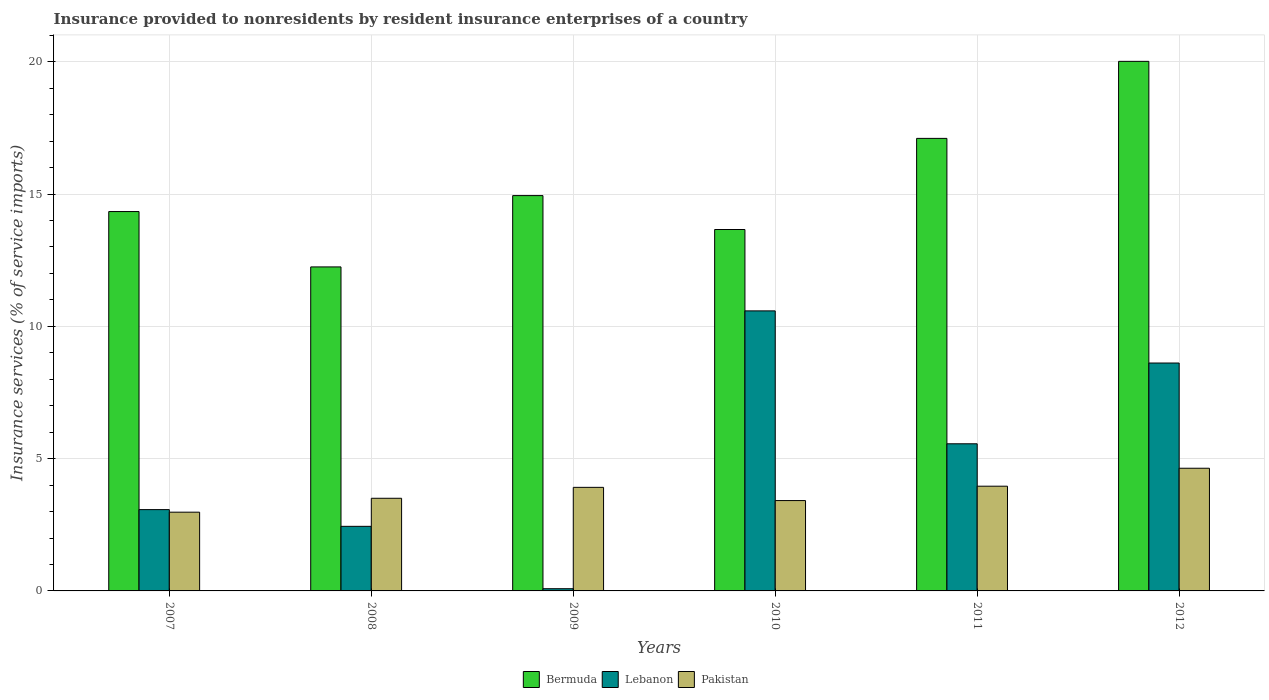How many bars are there on the 4th tick from the left?
Keep it short and to the point. 3. How many bars are there on the 2nd tick from the right?
Make the answer very short. 3. What is the label of the 1st group of bars from the left?
Your answer should be compact. 2007. In how many cases, is the number of bars for a given year not equal to the number of legend labels?
Your answer should be compact. 0. What is the insurance provided to nonresidents in Bermuda in 2011?
Ensure brevity in your answer.  17.1. Across all years, what is the maximum insurance provided to nonresidents in Bermuda?
Ensure brevity in your answer.  20.02. Across all years, what is the minimum insurance provided to nonresidents in Lebanon?
Your answer should be compact. 0.08. In which year was the insurance provided to nonresidents in Lebanon maximum?
Provide a succinct answer. 2010. In which year was the insurance provided to nonresidents in Lebanon minimum?
Offer a very short reply. 2009. What is the total insurance provided to nonresidents in Lebanon in the graph?
Offer a very short reply. 30.36. What is the difference between the insurance provided to nonresidents in Bermuda in 2008 and that in 2010?
Provide a short and direct response. -1.41. What is the difference between the insurance provided to nonresidents in Pakistan in 2007 and the insurance provided to nonresidents in Lebanon in 2009?
Make the answer very short. 2.89. What is the average insurance provided to nonresidents in Lebanon per year?
Offer a very short reply. 5.06. In the year 2011, what is the difference between the insurance provided to nonresidents in Pakistan and insurance provided to nonresidents in Lebanon?
Give a very brief answer. -1.6. In how many years, is the insurance provided to nonresidents in Bermuda greater than 1 %?
Your answer should be very brief. 6. What is the ratio of the insurance provided to nonresidents in Pakistan in 2007 to that in 2009?
Your answer should be compact. 0.76. Is the insurance provided to nonresidents in Pakistan in 2009 less than that in 2010?
Provide a succinct answer. No. What is the difference between the highest and the second highest insurance provided to nonresidents in Bermuda?
Keep it short and to the point. 2.91. What is the difference between the highest and the lowest insurance provided to nonresidents in Lebanon?
Offer a very short reply. 10.5. In how many years, is the insurance provided to nonresidents in Bermuda greater than the average insurance provided to nonresidents in Bermuda taken over all years?
Ensure brevity in your answer.  2. What does the 2nd bar from the left in 2008 represents?
Your response must be concise. Lebanon. What does the 2nd bar from the right in 2007 represents?
Offer a very short reply. Lebanon. Does the graph contain any zero values?
Your answer should be very brief. No. Does the graph contain grids?
Ensure brevity in your answer.  Yes. How are the legend labels stacked?
Ensure brevity in your answer.  Horizontal. What is the title of the graph?
Your response must be concise. Insurance provided to nonresidents by resident insurance enterprises of a country. What is the label or title of the Y-axis?
Give a very brief answer. Insurance services (% of service imports). What is the Insurance services (% of service imports) of Bermuda in 2007?
Your response must be concise. 14.34. What is the Insurance services (% of service imports) in Lebanon in 2007?
Provide a succinct answer. 3.07. What is the Insurance services (% of service imports) of Pakistan in 2007?
Offer a very short reply. 2.98. What is the Insurance services (% of service imports) in Bermuda in 2008?
Offer a terse response. 12.25. What is the Insurance services (% of service imports) of Lebanon in 2008?
Your answer should be very brief. 2.44. What is the Insurance services (% of service imports) in Pakistan in 2008?
Your answer should be compact. 3.5. What is the Insurance services (% of service imports) in Bermuda in 2009?
Keep it short and to the point. 14.94. What is the Insurance services (% of service imports) of Lebanon in 2009?
Your response must be concise. 0.08. What is the Insurance services (% of service imports) in Pakistan in 2009?
Make the answer very short. 3.91. What is the Insurance services (% of service imports) of Bermuda in 2010?
Make the answer very short. 13.66. What is the Insurance services (% of service imports) of Lebanon in 2010?
Your response must be concise. 10.58. What is the Insurance services (% of service imports) of Pakistan in 2010?
Provide a succinct answer. 3.41. What is the Insurance services (% of service imports) in Bermuda in 2011?
Your answer should be very brief. 17.1. What is the Insurance services (% of service imports) in Lebanon in 2011?
Make the answer very short. 5.56. What is the Insurance services (% of service imports) of Pakistan in 2011?
Your answer should be very brief. 3.96. What is the Insurance services (% of service imports) of Bermuda in 2012?
Your answer should be compact. 20.02. What is the Insurance services (% of service imports) of Lebanon in 2012?
Ensure brevity in your answer.  8.61. What is the Insurance services (% of service imports) of Pakistan in 2012?
Offer a terse response. 4.64. Across all years, what is the maximum Insurance services (% of service imports) of Bermuda?
Keep it short and to the point. 20.02. Across all years, what is the maximum Insurance services (% of service imports) of Lebanon?
Make the answer very short. 10.58. Across all years, what is the maximum Insurance services (% of service imports) of Pakistan?
Your response must be concise. 4.64. Across all years, what is the minimum Insurance services (% of service imports) of Bermuda?
Provide a short and direct response. 12.25. Across all years, what is the minimum Insurance services (% of service imports) in Lebanon?
Offer a very short reply. 0.08. Across all years, what is the minimum Insurance services (% of service imports) in Pakistan?
Your answer should be compact. 2.98. What is the total Insurance services (% of service imports) of Bermuda in the graph?
Offer a very short reply. 92.3. What is the total Insurance services (% of service imports) of Lebanon in the graph?
Your response must be concise. 30.36. What is the total Insurance services (% of service imports) in Pakistan in the graph?
Your answer should be compact. 22.4. What is the difference between the Insurance services (% of service imports) in Bermuda in 2007 and that in 2008?
Give a very brief answer. 2.09. What is the difference between the Insurance services (% of service imports) in Lebanon in 2007 and that in 2008?
Make the answer very short. 0.63. What is the difference between the Insurance services (% of service imports) in Pakistan in 2007 and that in 2008?
Offer a terse response. -0.53. What is the difference between the Insurance services (% of service imports) in Bermuda in 2007 and that in 2009?
Provide a succinct answer. -0.6. What is the difference between the Insurance services (% of service imports) of Lebanon in 2007 and that in 2009?
Make the answer very short. 2.99. What is the difference between the Insurance services (% of service imports) in Pakistan in 2007 and that in 2009?
Your answer should be very brief. -0.94. What is the difference between the Insurance services (% of service imports) of Bermuda in 2007 and that in 2010?
Your response must be concise. 0.68. What is the difference between the Insurance services (% of service imports) of Lebanon in 2007 and that in 2010?
Provide a succinct answer. -7.51. What is the difference between the Insurance services (% of service imports) in Pakistan in 2007 and that in 2010?
Provide a short and direct response. -0.44. What is the difference between the Insurance services (% of service imports) in Bermuda in 2007 and that in 2011?
Give a very brief answer. -2.77. What is the difference between the Insurance services (% of service imports) in Lebanon in 2007 and that in 2011?
Offer a very short reply. -2.49. What is the difference between the Insurance services (% of service imports) of Pakistan in 2007 and that in 2011?
Your response must be concise. -0.98. What is the difference between the Insurance services (% of service imports) of Bermuda in 2007 and that in 2012?
Keep it short and to the point. -5.68. What is the difference between the Insurance services (% of service imports) in Lebanon in 2007 and that in 2012?
Provide a short and direct response. -5.54. What is the difference between the Insurance services (% of service imports) in Pakistan in 2007 and that in 2012?
Give a very brief answer. -1.66. What is the difference between the Insurance services (% of service imports) in Bermuda in 2008 and that in 2009?
Your answer should be very brief. -2.7. What is the difference between the Insurance services (% of service imports) in Lebanon in 2008 and that in 2009?
Ensure brevity in your answer.  2.36. What is the difference between the Insurance services (% of service imports) of Pakistan in 2008 and that in 2009?
Keep it short and to the point. -0.41. What is the difference between the Insurance services (% of service imports) in Bermuda in 2008 and that in 2010?
Give a very brief answer. -1.41. What is the difference between the Insurance services (% of service imports) in Lebanon in 2008 and that in 2010?
Offer a very short reply. -8.14. What is the difference between the Insurance services (% of service imports) of Pakistan in 2008 and that in 2010?
Your response must be concise. 0.09. What is the difference between the Insurance services (% of service imports) in Bermuda in 2008 and that in 2011?
Your answer should be compact. -4.86. What is the difference between the Insurance services (% of service imports) of Lebanon in 2008 and that in 2011?
Your response must be concise. -3.12. What is the difference between the Insurance services (% of service imports) in Pakistan in 2008 and that in 2011?
Your response must be concise. -0.46. What is the difference between the Insurance services (% of service imports) in Bermuda in 2008 and that in 2012?
Your answer should be compact. -7.77. What is the difference between the Insurance services (% of service imports) of Lebanon in 2008 and that in 2012?
Offer a very short reply. -6.17. What is the difference between the Insurance services (% of service imports) of Pakistan in 2008 and that in 2012?
Offer a very short reply. -1.14. What is the difference between the Insurance services (% of service imports) of Bermuda in 2009 and that in 2010?
Provide a succinct answer. 1.28. What is the difference between the Insurance services (% of service imports) of Lebanon in 2009 and that in 2010?
Give a very brief answer. -10.5. What is the difference between the Insurance services (% of service imports) of Pakistan in 2009 and that in 2010?
Your response must be concise. 0.5. What is the difference between the Insurance services (% of service imports) in Bermuda in 2009 and that in 2011?
Your answer should be compact. -2.16. What is the difference between the Insurance services (% of service imports) of Lebanon in 2009 and that in 2011?
Offer a terse response. -5.48. What is the difference between the Insurance services (% of service imports) in Pakistan in 2009 and that in 2011?
Ensure brevity in your answer.  -0.04. What is the difference between the Insurance services (% of service imports) of Bermuda in 2009 and that in 2012?
Your answer should be compact. -5.07. What is the difference between the Insurance services (% of service imports) in Lebanon in 2009 and that in 2012?
Offer a very short reply. -8.53. What is the difference between the Insurance services (% of service imports) of Pakistan in 2009 and that in 2012?
Your answer should be very brief. -0.72. What is the difference between the Insurance services (% of service imports) in Bermuda in 2010 and that in 2011?
Provide a short and direct response. -3.44. What is the difference between the Insurance services (% of service imports) in Lebanon in 2010 and that in 2011?
Your answer should be compact. 5.02. What is the difference between the Insurance services (% of service imports) in Pakistan in 2010 and that in 2011?
Make the answer very short. -0.54. What is the difference between the Insurance services (% of service imports) in Bermuda in 2010 and that in 2012?
Offer a very short reply. -6.36. What is the difference between the Insurance services (% of service imports) of Lebanon in 2010 and that in 2012?
Provide a short and direct response. 1.97. What is the difference between the Insurance services (% of service imports) in Pakistan in 2010 and that in 2012?
Offer a terse response. -1.22. What is the difference between the Insurance services (% of service imports) of Bermuda in 2011 and that in 2012?
Provide a short and direct response. -2.91. What is the difference between the Insurance services (% of service imports) in Lebanon in 2011 and that in 2012?
Offer a very short reply. -3.05. What is the difference between the Insurance services (% of service imports) in Pakistan in 2011 and that in 2012?
Provide a succinct answer. -0.68. What is the difference between the Insurance services (% of service imports) of Bermuda in 2007 and the Insurance services (% of service imports) of Lebanon in 2008?
Provide a succinct answer. 11.9. What is the difference between the Insurance services (% of service imports) of Bermuda in 2007 and the Insurance services (% of service imports) of Pakistan in 2008?
Your response must be concise. 10.84. What is the difference between the Insurance services (% of service imports) of Lebanon in 2007 and the Insurance services (% of service imports) of Pakistan in 2008?
Make the answer very short. -0.43. What is the difference between the Insurance services (% of service imports) in Bermuda in 2007 and the Insurance services (% of service imports) in Lebanon in 2009?
Make the answer very short. 14.25. What is the difference between the Insurance services (% of service imports) in Bermuda in 2007 and the Insurance services (% of service imports) in Pakistan in 2009?
Give a very brief answer. 10.42. What is the difference between the Insurance services (% of service imports) in Lebanon in 2007 and the Insurance services (% of service imports) in Pakistan in 2009?
Offer a terse response. -0.84. What is the difference between the Insurance services (% of service imports) in Bermuda in 2007 and the Insurance services (% of service imports) in Lebanon in 2010?
Your answer should be compact. 3.75. What is the difference between the Insurance services (% of service imports) of Bermuda in 2007 and the Insurance services (% of service imports) of Pakistan in 2010?
Offer a very short reply. 10.92. What is the difference between the Insurance services (% of service imports) in Lebanon in 2007 and the Insurance services (% of service imports) in Pakistan in 2010?
Provide a short and direct response. -0.34. What is the difference between the Insurance services (% of service imports) of Bermuda in 2007 and the Insurance services (% of service imports) of Lebanon in 2011?
Your answer should be very brief. 8.78. What is the difference between the Insurance services (% of service imports) in Bermuda in 2007 and the Insurance services (% of service imports) in Pakistan in 2011?
Your answer should be very brief. 10.38. What is the difference between the Insurance services (% of service imports) of Lebanon in 2007 and the Insurance services (% of service imports) of Pakistan in 2011?
Make the answer very short. -0.89. What is the difference between the Insurance services (% of service imports) of Bermuda in 2007 and the Insurance services (% of service imports) of Lebanon in 2012?
Your answer should be very brief. 5.72. What is the difference between the Insurance services (% of service imports) in Bermuda in 2007 and the Insurance services (% of service imports) in Pakistan in 2012?
Ensure brevity in your answer.  9.7. What is the difference between the Insurance services (% of service imports) of Lebanon in 2007 and the Insurance services (% of service imports) of Pakistan in 2012?
Your answer should be compact. -1.56. What is the difference between the Insurance services (% of service imports) of Bermuda in 2008 and the Insurance services (% of service imports) of Lebanon in 2009?
Offer a very short reply. 12.16. What is the difference between the Insurance services (% of service imports) in Bermuda in 2008 and the Insurance services (% of service imports) in Pakistan in 2009?
Ensure brevity in your answer.  8.33. What is the difference between the Insurance services (% of service imports) of Lebanon in 2008 and the Insurance services (% of service imports) of Pakistan in 2009?
Provide a succinct answer. -1.47. What is the difference between the Insurance services (% of service imports) in Bermuda in 2008 and the Insurance services (% of service imports) in Lebanon in 2010?
Offer a terse response. 1.66. What is the difference between the Insurance services (% of service imports) of Bermuda in 2008 and the Insurance services (% of service imports) of Pakistan in 2010?
Give a very brief answer. 8.83. What is the difference between the Insurance services (% of service imports) of Lebanon in 2008 and the Insurance services (% of service imports) of Pakistan in 2010?
Offer a very short reply. -0.97. What is the difference between the Insurance services (% of service imports) of Bermuda in 2008 and the Insurance services (% of service imports) of Lebanon in 2011?
Your response must be concise. 6.68. What is the difference between the Insurance services (% of service imports) of Bermuda in 2008 and the Insurance services (% of service imports) of Pakistan in 2011?
Your answer should be compact. 8.29. What is the difference between the Insurance services (% of service imports) in Lebanon in 2008 and the Insurance services (% of service imports) in Pakistan in 2011?
Keep it short and to the point. -1.52. What is the difference between the Insurance services (% of service imports) in Bermuda in 2008 and the Insurance services (% of service imports) in Lebanon in 2012?
Provide a short and direct response. 3.63. What is the difference between the Insurance services (% of service imports) of Bermuda in 2008 and the Insurance services (% of service imports) of Pakistan in 2012?
Offer a terse response. 7.61. What is the difference between the Insurance services (% of service imports) in Lebanon in 2008 and the Insurance services (% of service imports) in Pakistan in 2012?
Your answer should be very brief. -2.2. What is the difference between the Insurance services (% of service imports) of Bermuda in 2009 and the Insurance services (% of service imports) of Lebanon in 2010?
Ensure brevity in your answer.  4.36. What is the difference between the Insurance services (% of service imports) of Bermuda in 2009 and the Insurance services (% of service imports) of Pakistan in 2010?
Your answer should be very brief. 11.53. What is the difference between the Insurance services (% of service imports) in Lebanon in 2009 and the Insurance services (% of service imports) in Pakistan in 2010?
Your answer should be very brief. -3.33. What is the difference between the Insurance services (% of service imports) in Bermuda in 2009 and the Insurance services (% of service imports) in Lebanon in 2011?
Keep it short and to the point. 9.38. What is the difference between the Insurance services (% of service imports) of Bermuda in 2009 and the Insurance services (% of service imports) of Pakistan in 2011?
Offer a very short reply. 10.98. What is the difference between the Insurance services (% of service imports) in Lebanon in 2009 and the Insurance services (% of service imports) in Pakistan in 2011?
Offer a terse response. -3.87. What is the difference between the Insurance services (% of service imports) in Bermuda in 2009 and the Insurance services (% of service imports) in Lebanon in 2012?
Ensure brevity in your answer.  6.33. What is the difference between the Insurance services (% of service imports) in Bermuda in 2009 and the Insurance services (% of service imports) in Pakistan in 2012?
Provide a short and direct response. 10.3. What is the difference between the Insurance services (% of service imports) of Lebanon in 2009 and the Insurance services (% of service imports) of Pakistan in 2012?
Your answer should be compact. -4.55. What is the difference between the Insurance services (% of service imports) of Bermuda in 2010 and the Insurance services (% of service imports) of Lebanon in 2011?
Provide a short and direct response. 8.1. What is the difference between the Insurance services (% of service imports) in Bermuda in 2010 and the Insurance services (% of service imports) in Pakistan in 2011?
Keep it short and to the point. 9.7. What is the difference between the Insurance services (% of service imports) of Lebanon in 2010 and the Insurance services (% of service imports) of Pakistan in 2011?
Offer a terse response. 6.63. What is the difference between the Insurance services (% of service imports) of Bermuda in 2010 and the Insurance services (% of service imports) of Lebanon in 2012?
Your response must be concise. 5.05. What is the difference between the Insurance services (% of service imports) of Bermuda in 2010 and the Insurance services (% of service imports) of Pakistan in 2012?
Offer a terse response. 9.02. What is the difference between the Insurance services (% of service imports) of Lebanon in 2010 and the Insurance services (% of service imports) of Pakistan in 2012?
Make the answer very short. 5.95. What is the difference between the Insurance services (% of service imports) of Bermuda in 2011 and the Insurance services (% of service imports) of Lebanon in 2012?
Your response must be concise. 8.49. What is the difference between the Insurance services (% of service imports) in Bermuda in 2011 and the Insurance services (% of service imports) in Pakistan in 2012?
Make the answer very short. 12.47. What is the difference between the Insurance services (% of service imports) in Lebanon in 2011 and the Insurance services (% of service imports) in Pakistan in 2012?
Offer a terse response. 0.92. What is the average Insurance services (% of service imports) of Bermuda per year?
Your response must be concise. 15.38. What is the average Insurance services (% of service imports) of Lebanon per year?
Provide a succinct answer. 5.06. What is the average Insurance services (% of service imports) in Pakistan per year?
Keep it short and to the point. 3.73. In the year 2007, what is the difference between the Insurance services (% of service imports) in Bermuda and Insurance services (% of service imports) in Lebanon?
Give a very brief answer. 11.27. In the year 2007, what is the difference between the Insurance services (% of service imports) in Bermuda and Insurance services (% of service imports) in Pakistan?
Ensure brevity in your answer.  11.36. In the year 2007, what is the difference between the Insurance services (% of service imports) of Lebanon and Insurance services (% of service imports) of Pakistan?
Ensure brevity in your answer.  0.1. In the year 2008, what is the difference between the Insurance services (% of service imports) of Bermuda and Insurance services (% of service imports) of Lebanon?
Give a very brief answer. 9.8. In the year 2008, what is the difference between the Insurance services (% of service imports) in Bermuda and Insurance services (% of service imports) in Pakistan?
Your answer should be compact. 8.74. In the year 2008, what is the difference between the Insurance services (% of service imports) in Lebanon and Insurance services (% of service imports) in Pakistan?
Offer a very short reply. -1.06. In the year 2009, what is the difference between the Insurance services (% of service imports) of Bermuda and Insurance services (% of service imports) of Lebanon?
Make the answer very short. 14.86. In the year 2009, what is the difference between the Insurance services (% of service imports) of Bermuda and Insurance services (% of service imports) of Pakistan?
Give a very brief answer. 11.03. In the year 2009, what is the difference between the Insurance services (% of service imports) of Lebanon and Insurance services (% of service imports) of Pakistan?
Make the answer very short. -3.83. In the year 2010, what is the difference between the Insurance services (% of service imports) of Bermuda and Insurance services (% of service imports) of Lebanon?
Your answer should be compact. 3.08. In the year 2010, what is the difference between the Insurance services (% of service imports) of Bermuda and Insurance services (% of service imports) of Pakistan?
Give a very brief answer. 10.25. In the year 2010, what is the difference between the Insurance services (% of service imports) of Lebanon and Insurance services (% of service imports) of Pakistan?
Give a very brief answer. 7.17. In the year 2011, what is the difference between the Insurance services (% of service imports) in Bermuda and Insurance services (% of service imports) in Lebanon?
Make the answer very short. 11.54. In the year 2011, what is the difference between the Insurance services (% of service imports) of Bermuda and Insurance services (% of service imports) of Pakistan?
Offer a very short reply. 13.15. In the year 2011, what is the difference between the Insurance services (% of service imports) of Lebanon and Insurance services (% of service imports) of Pakistan?
Your answer should be compact. 1.6. In the year 2012, what is the difference between the Insurance services (% of service imports) in Bermuda and Insurance services (% of service imports) in Lebanon?
Give a very brief answer. 11.4. In the year 2012, what is the difference between the Insurance services (% of service imports) in Bermuda and Insurance services (% of service imports) in Pakistan?
Make the answer very short. 15.38. In the year 2012, what is the difference between the Insurance services (% of service imports) in Lebanon and Insurance services (% of service imports) in Pakistan?
Keep it short and to the point. 3.98. What is the ratio of the Insurance services (% of service imports) in Bermuda in 2007 to that in 2008?
Offer a terse response. 1.17. What is the ratio of the Insurance services (% of service imports) of Lebanon in 2007 to that in 2008?
Your answer should be compact. 1.26. What is the ratio of the Insurance services (% of service imports) of Pakistan in 2007 to that in 2008?
Offer a very short reply. 0.85. What is the ratio of the Insurance services (% of service imports) in Bermuda in 2007 to that in 2009?
Give a very brief answer. 0.96. What is the ratio of the Insurance services (% of service imports) in Lebanon in 2007 to that in 2009?
Offer a terse response. 36.79. What is the ratio of the Insurance services (% of service imports) of Pakistan in 2007 to that in 2009?
Provide a short and direct response. 0.76. What is the ratio of the Insurance services (% of service imports) in Bermuda in 2007 to that in 2010?
Offer a very short reply. 1.05. What is the ratio of the Insurance services (% of service imports) in Lebanon in 2007 to that in 2010?
Your answer should be very brief. 0.29. What is the ratio of the Insurance services (% of service imports) of Pakistan in 2007 to that in 2010?
Provide a short and direct response. 0.87. What is the ratio of the Insurance services (% of service imports) of Bermuda in 2007 to that in 2011?
Your answer should be very brief. 0.84. What is the ratio of the Insurance services (% of service imports) of Lebanon in 2007 to that in 2011?
Offer a very short reply. 0.55. What is the ratio of the Insurance services (% of service imports) of Pakistan in 2007 to that in 2011?
Your response must be concise. 0.75. What is the ratio of the Insurance services (% of service imports) in Bermuda in 2007 to that in 2012?
Provide a short and direct response. 0.72. What is the ratio of the Insurance services (% of service imports) of Lebanon in 2007 to that in 2012?
Your response must be concise. 0.36. What is the ratio of the Insurance services (% of service imports) of Pakistan in 2007 to that in 2012?
Provide a succinct answer. 0.64. What is the ratio of the Insurance services (% of service imports) in Bermuda in 2008 to that in 2009?
Ensure brevity in your answer.  0.82. What is the ratio of the Insurance services (% of service imports) of Lebanon in 2008 to that in 2009?
Offer a very short reply. 29.23. What is the ratio of the Insurance services (% of service imports) of Pakistan in 2008 to that in 2009?
Keep it short and to the point. 0.89. What is the ratio of the Insurance services (% of service imports) in Bermuda in 2008 to that in 2010?
Provide a short and direct response. 0.9. What is the ratio of the Insurance services (% of service imports) of Lebanon in 2008 to that in 2010?
Your answer should be very brief. 0.23. What is the ratio of the Insurance services (% of service imports) of Pakistan in 2008 to that in 2010?
Your response must be concise. 1.03. What is the ratio of the Insurance services (% of service imports) of Bermuda in 2008 to that in 2011?
Your response must be concise. 0.72. What is the ratio of the Insurance services (% of service imports) in Lebanon in 2008 to that in 2011?
Give a very brief answer. 0.44. What is the ratio of the Insurance services (% of service imports) in Pakistan in 2008 to that in 2011?
Provide a short and direct response. 0.88. What is the ratio of the Insurance services (% of service imports) in Bermuda in 2008 to that in 2012?
Your answer should be compact. 0.61. What is the ratio of the Insurance services (% of service imports) of Lebanon in 2008 to that in 2012?
Provide a short and direct response. 0.28. What is the ratio of the Insurance services (% of service imports) of Pakistan in 2008 to that in 2012?
Ensure brevity in your answer.  0.76. What is the ratio of the Insurance services (% of service imports) of Bermuda in 2009 to that in 2010?
Offer a very short reply. 1.09. What is the ratio of the Insurance services (% of service imports) in Lebanon in 2009 to that in 2010?
Ensure brevity in your answer.  0.01. What is the ratio of the Insurance services (% of service imports) of Pakistan in 2009 to that in 2010?
Give a very brief answer. 1.15. What is the ratio of the Insurance services (% of service imports) in Bermuda in 2009 to that in 2011?
Your answer should be very brief. 0.87. What is the ratio of the Insurance services (% of service imports) of Lebanon in 2009 to that in 2011?
Your response must be concise. 0.01. What is the ratio of the Insurance services (% of service imports) of Pakistan in 2009 to that in 2011?
Keep it short and to the point. 0.99. What is the ratio of the Insurance services (% of service imports) in Bermuda in 2009 to that in 2012?
Offer a very short reply. 0.75. What is the ratio of the Insurance services (% of service imports) of Lebanon in 2009 to that in 2012?
Your response must be concise. 0.01. What is the ratio of the Insurance services (% of service imports) in Pakistan in 2009 to that in 2012?
Offer a very short reply. 0.84. What is the ratio of the Insurance services (% of service imports) of Bermuda in 2010 to that in 2011?
Ensure brevity in your answer.  0.8. What is the ratio of the Insurance services (% of service imports) of Lebanon in 2010 to that in 2011?
Provide a succinct answer. 1.9. What is the ratio of the Insurance services (% of service imports) in Pakistan in 2010 to that in 2011?
Your response must be concise. 0.86. What is the ratio of the Insurance services (% of service imports) of Bermuda in 2010 to that in 2012?
Keep it short and to the point. 0.68. What is the ratio of the Insurance services (% of service imports) in Lebanon in 2010 to that in 2012?
Your response must be concise. 1.23. What is the ratio of the Insurance services (% of service imports) in Pakistan in 2010 to that in 2012?
Your answer should be very brief. 0.74. What is the ratio of the Insurance services (% of service imports) in Bermuda in 2011 to that in 2012?
Your response must be concise. 0.85. What is the ratio of the Insurance services (% of service imports) in Lebanon in 2011 to that in 2012?
Provide a short and direct response. 0.65. What is the ratio of the Insurance services (% of service imports) in Pakistan in 2011 to that in 2012?
Make the answer very short. 0.85. What is the difference between the highest and the second highest Insurance services (% of service imports) of Bermuda?
Your answer should be very brief. 2.91. What is the difference between the highest and the second highest Insurance services (% of service imports) in Lebanon?
Ensure brevity in your answer.  1.97. What is the difference between the highest and the second highest Insurance services (% of service imports) of Pakistan?
Offer a very short reply. 0.68. What is the difference between the highest and the lowest Insurance services (% of service imports) in Bermuda?
Your response must be concise. 7.77. What is the difference between the highest and the lowest Insurance services (% of service imports) of Lebanon?
Give a very brief answer. 10.5. What is the difference between the highest and the lowest Insurance services (% of service imports) of Pakistan?
Make the answer very short. 1.66. 